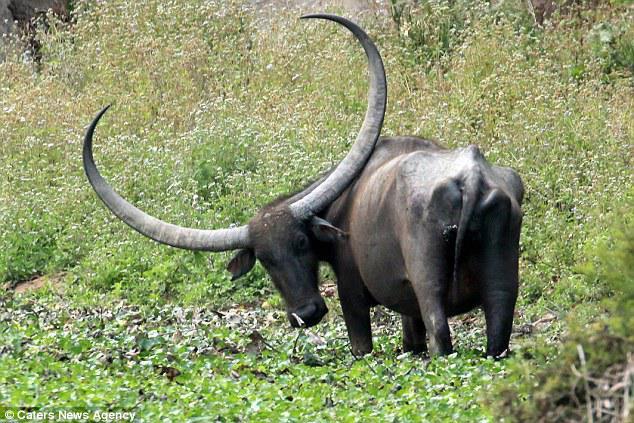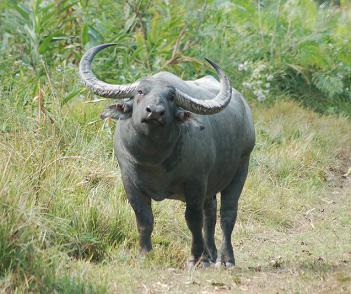The first image is the image on the left, the second image is the image on the right. Considering the images on both sides, is "One image contains exactly two adult oxen." valid? Answer yes or no. No. 